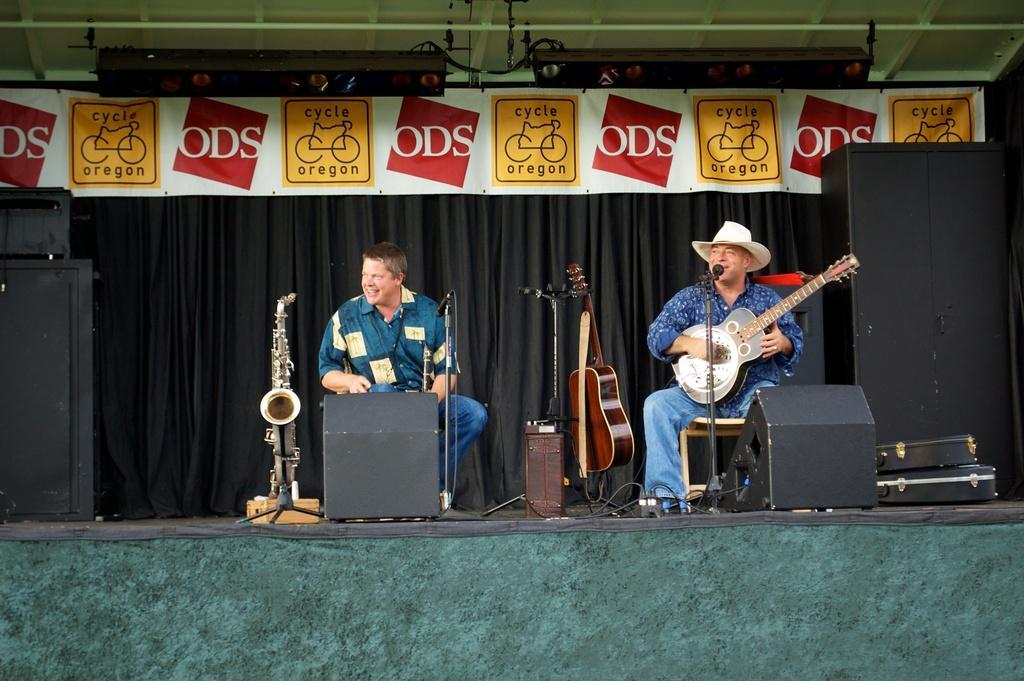How would you summarize this image in a sentence or two? This picture describes about two people the right side person is playing guitar in front of microphone and we can see some musical instruments here and also we can see hoarding and curtains. 